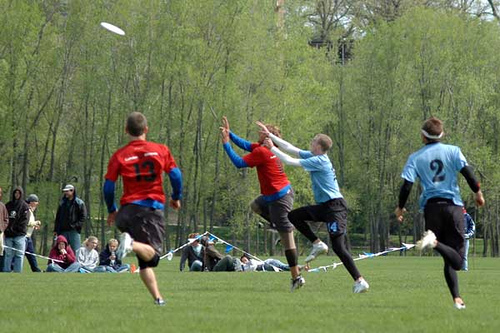Describe the setting and atmosphere surrounding the game. The game is taking place on a lush green field, which suggests an outdoor park or recreational area. The overcast sky implies it might be a cool day. Spectators lining the field add to the competitive atmosphere, watching intently as the players are focused on the play. 